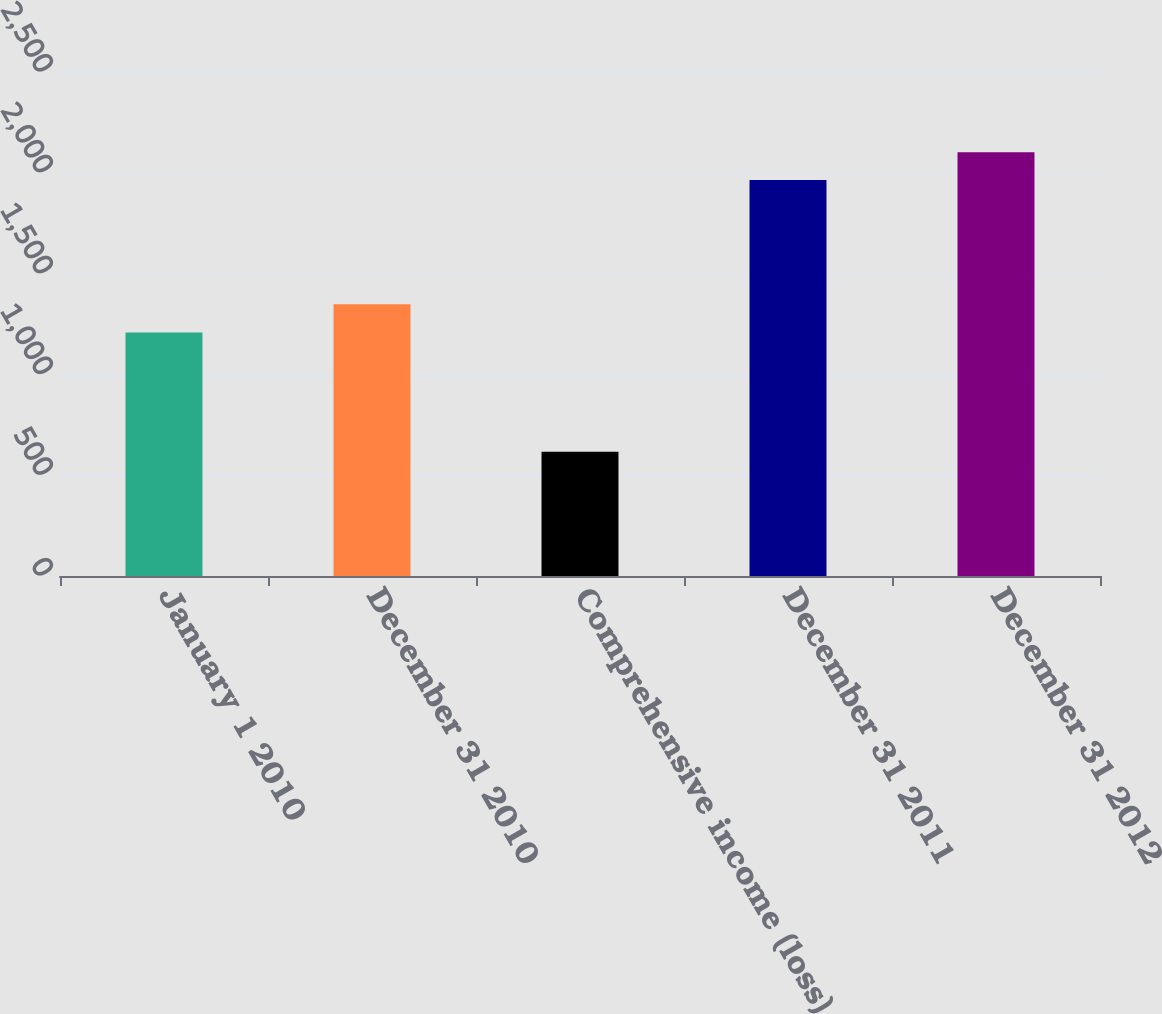Convert chart to OTSL. <chart><loc_0><loc_0><loc_500><loc_500><bar_chart><fcel>January 1 2010<fcel>December 31 2010<fcel>Comprehensive income (loss)<fcel>December 31 2011<fcel>December 31 2012<nl><fcel>1208<fcel>1348<fcel>616<fcel>1964<fcel>2101.4<nl></chart> 